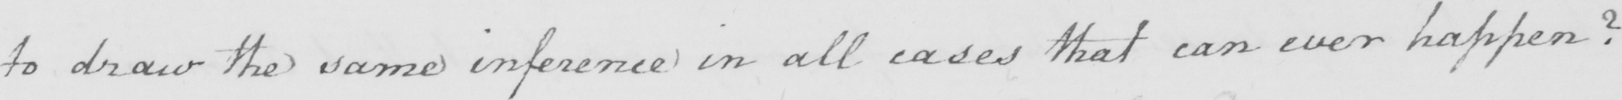Transcribe the text shown in this historical manuscript line. to draw the same inference in all cases that can ever happen ? 